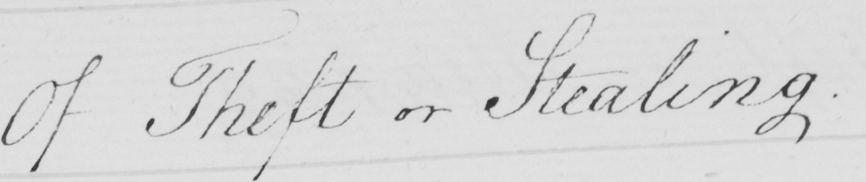Please provide the text content of this handwritten line. Of Theft or Stealing . 